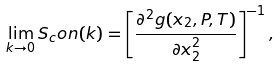Convert formula to latex. <formula><loc_0><loc_0><loc_500><loc_500>\lim _ { k \to 0 } S _ { c } o n ( k ) = \left [ \frac { \partial ^ { 2 } g ( x _ { 2 } , P , T ) } { \partial x _ { 2 } ^ { 2 } } \right ] ^ { - 1 } ,</formula> 